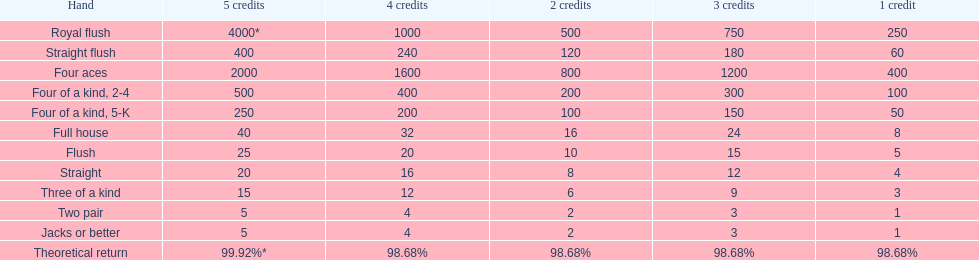The number of flush wins at one credit to equal one flush win at 5 credits. 5. 